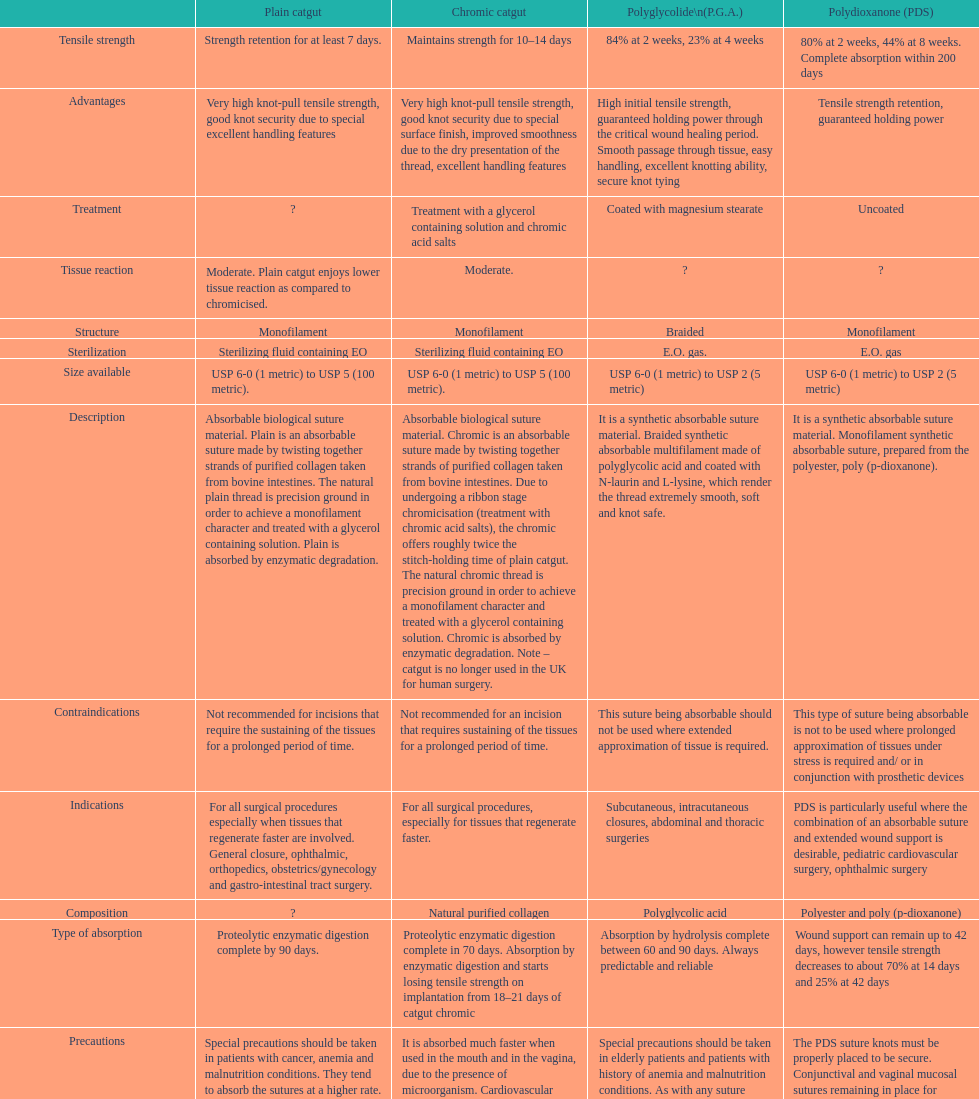What is the structure other than monofilament Braided. 